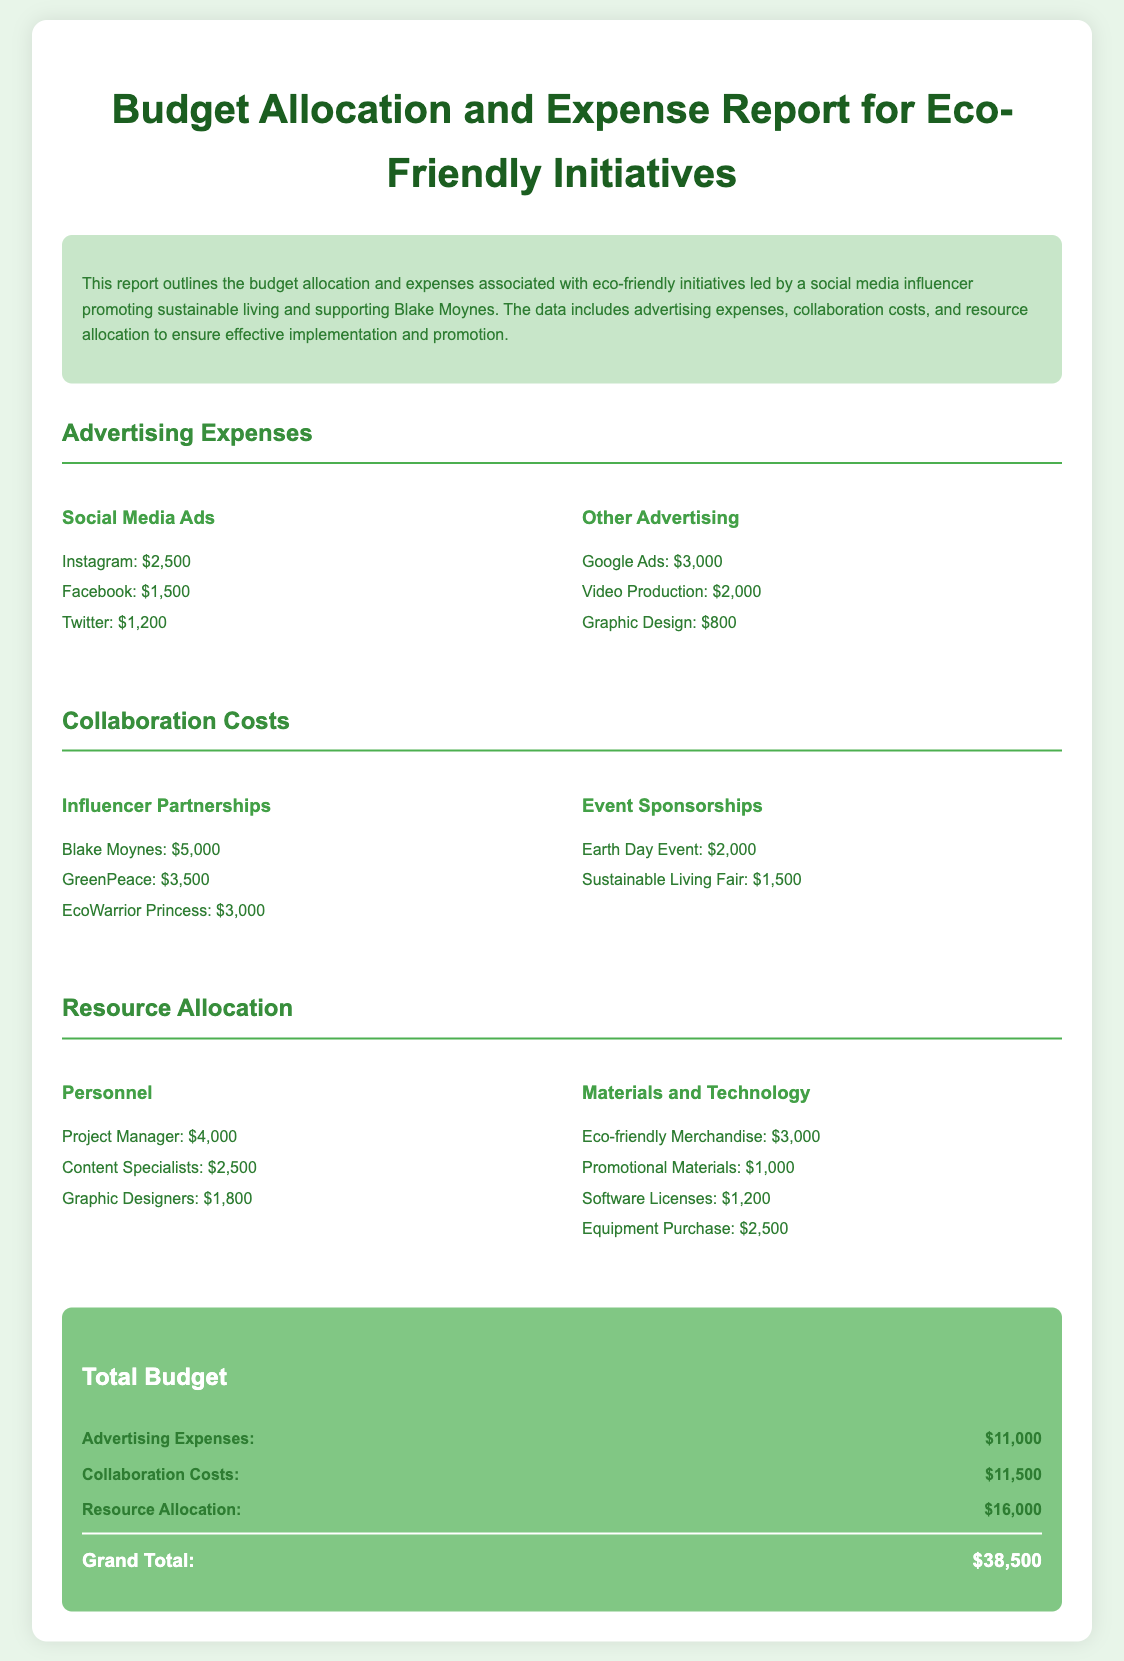What is the total budget for eco-friendly initiatives? The total budget is the grand total listed in the document, which combines all expenses.
Answer: $38,500 How much is allocated for advertising expenses? The document specifies the amount allocated for advertising expenses, detailed in a separate section.
Answer: $11,000 What is the cost of the partnership with Blake Moynes? The amount spent on the partnership with Blake Moynes is listed under influencer partnerships.
Answer: $5,000 Which platform has the highest advertising cost? The advertising costs are detailed by platform, revealing which one has the highest expenditure.
Answer: Instagram What is the combined expense for personnel in resource allocation? The personnel costs are individually listed, requiring addition to find the total in the resource allocation section.
Answer: $8,300 What is the expense for eco-friendly merchandise? The document provides a specific expense related to materials used for eco-friendly initiatives.
Answer: $3,000 How much was spent on the Sustainable Living Fair? The expense for this specific event is directly listed in the document.
Answer: $1,500 What is the total cost for collaboration costs? The total for collaboration costs is given as a sum of all listed collaborative expenses.
Answer: $11,500 How many advertising items are listed under Other Advertising? The document presents a list of advertising items, requiring a count of those specifically classified as "Other Advertising."
Answer: 3 